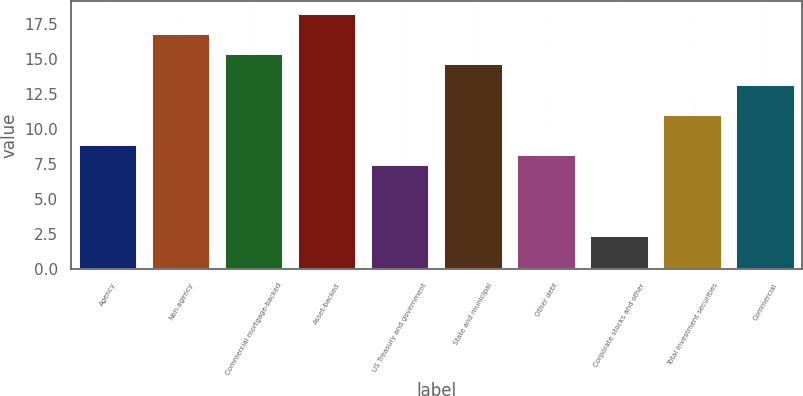Convert chart. <chart><loc_0><loc_0><loc_500><loc_500><bar_chart><fcel>Agency<fcel>Non-agency<fcel>Commercial mortgage-backed<fcel>Asset-backed<fcel>US Treasury and government<fcel>State and municipal<fcel>Other debt<fcel>Corporate stocks and other<fcel>Total investment securities<fcel>Commercial<nl><fcel>8.86<fcel>16.78<fcel>15.34<fcel>18.22<fcel>7.42<fcel>14.62<fcel>8.14<fcel>2.38<fcel>11.02<fcel>13.18<nl></chart> 